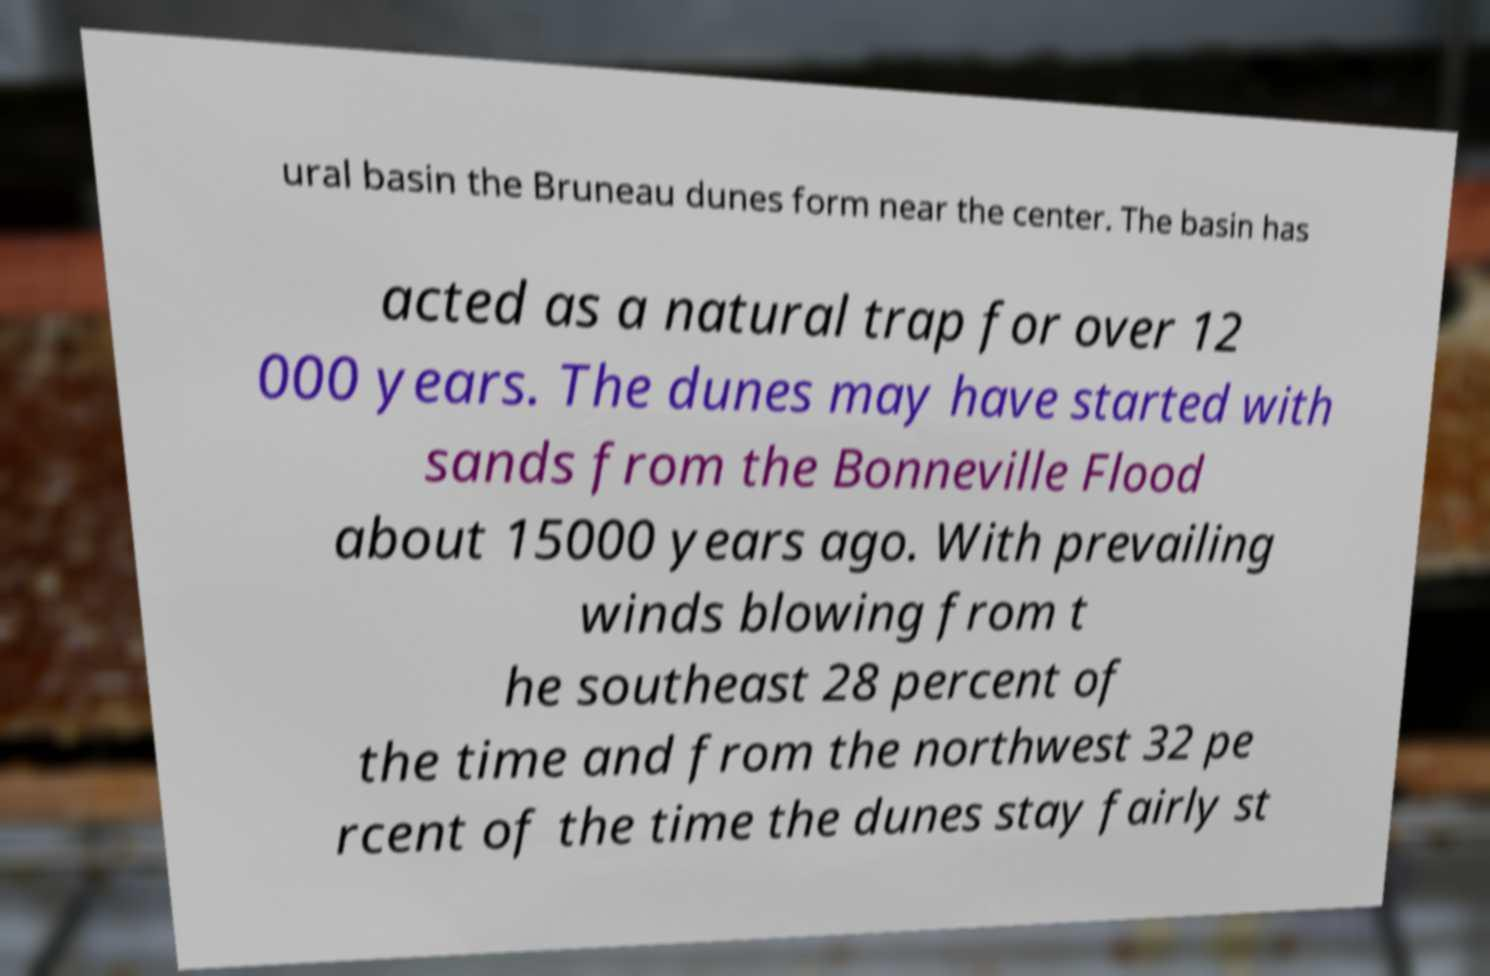Can you read and provide the text displayed in the image?This photo seems to have some interesting text. Can you extract and type it out for me? ural basin the Bruneau dunes form near the center. The basin has acted as a natural trap for over 12 000 years. The dunes may have started with sands from the Bonneville Flood about 15000 years ago. With prevailing winds blowing from t he southeast 28 percent of the time and from the northwest 32 pe rcent of the time the dunes stay fairly st 